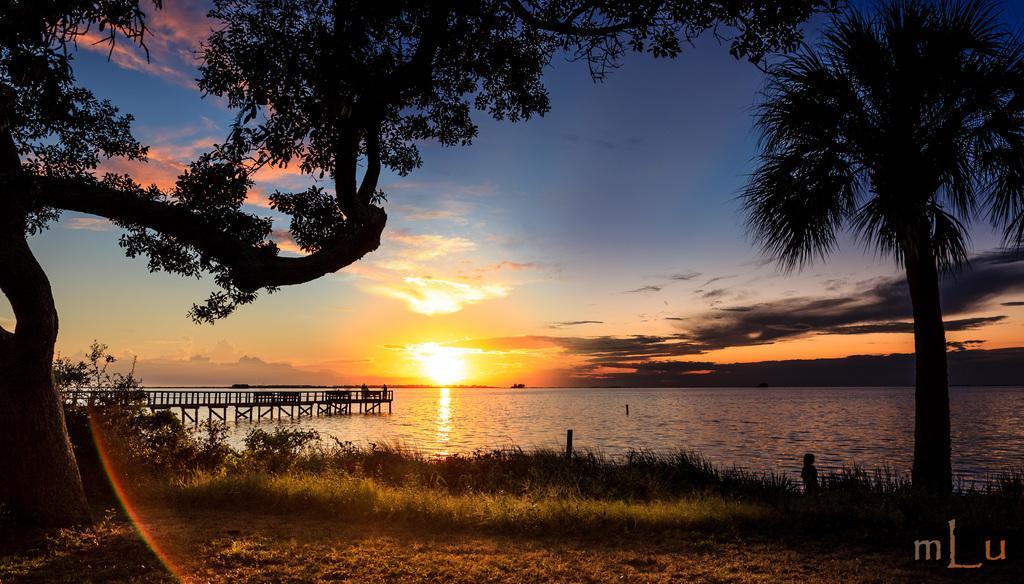In one or two sentences, can you explain what this image depicts? In this image I can see trees,lake ,grass ,sunset ,the sky and bridge on the lake and rainbow at the bottom 